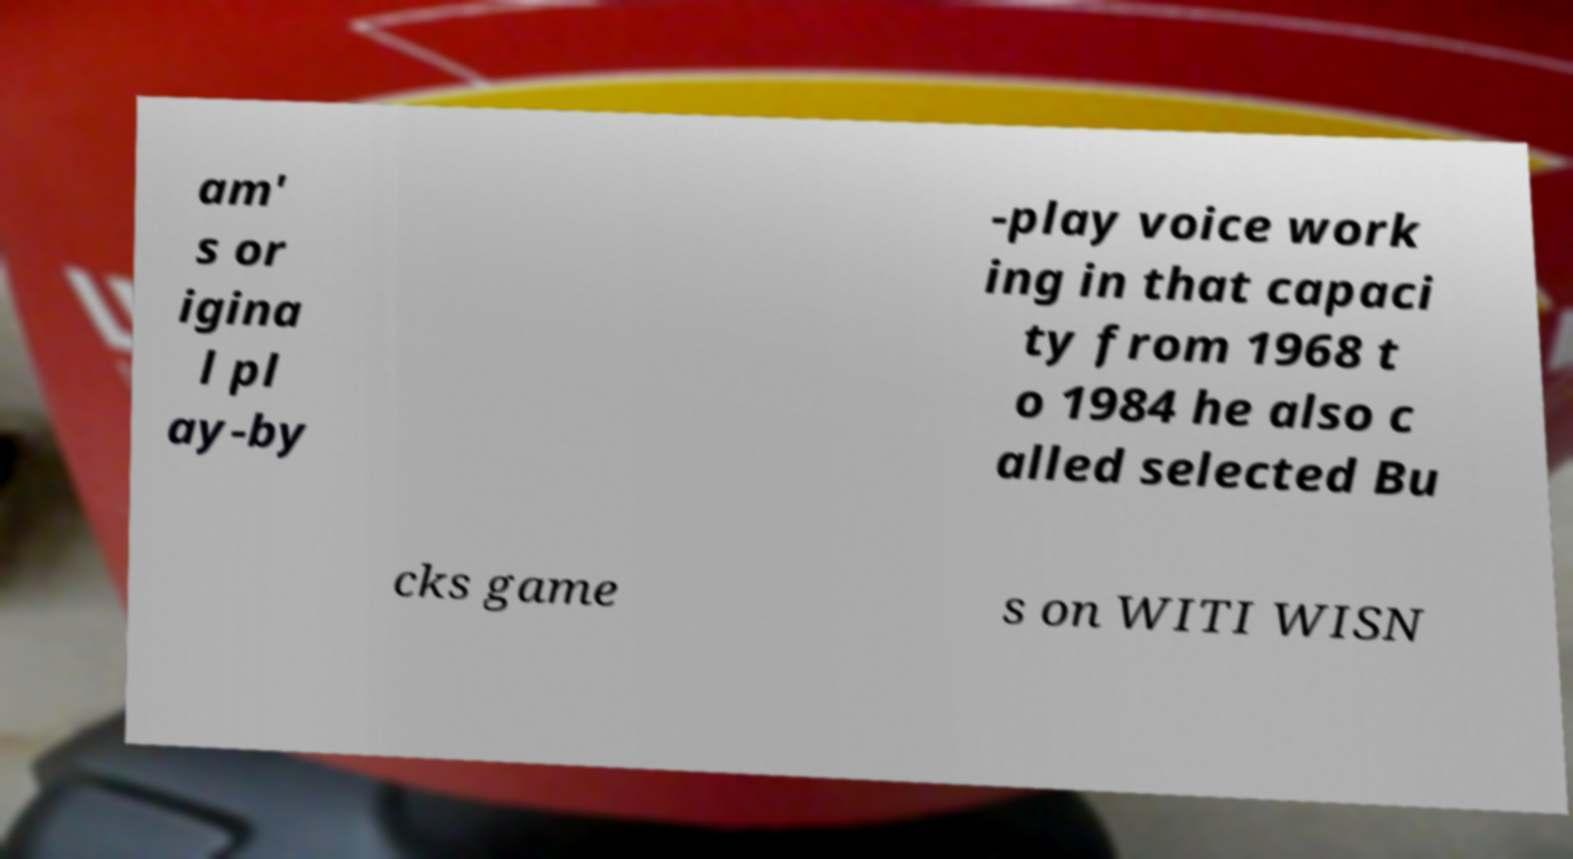For documentation purposes, I need the text within this image transcribed. Could you provide that? am' s or igina l pl ay-by -play voice work ing in that capaci ty from 1968 t o 1984 he also c alled selected Bu cks game s on WITI WISN 